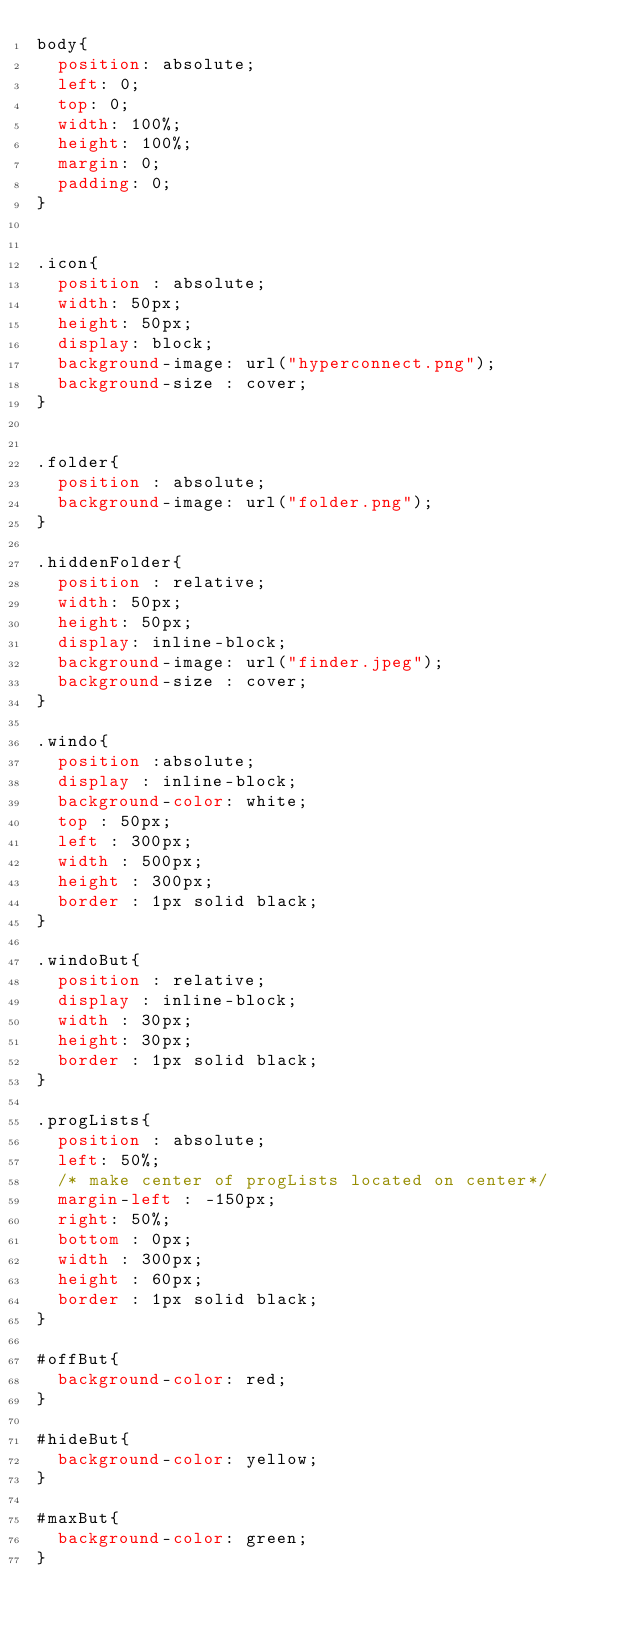Convert code to text. <code><loc_0><loc_0><loc_500><loc_500><_CSS_>body{
  position: absolute;
  left: 0;
  top: 0;
  width: 100%;
  height: 100%;
  margin: 0;
  padding: 0;
}


.icon{
  position : absolute;
  width: 50px;
  height: 50px;
  display: block;
  background-image: url("hyperconnect.png");
  background-size : cover;
}


.folder{
  position : absolute;
  background-image: url("folder.png");
}

.hiddenFolder{
  position : relative;
  width: 50px;
  height: 50px;
  display: inline-block;
  background-image: url("finder.jpeg");
  background-size : cover;
}

.windo{
  position :absolute;
  display : inline-block;
  background-color: white;
  top : 50px;
  left : 300px;
  width : 500px;
  height : 300px;
  border : 1px solid black;
}

.windoBut{
  position : relative;
  display : inline-block;
  width : 30px;
  height: 30px;
  border : 1px solid black;
}

.progLists{
  position : absolute;
  left: 50%;
  /* make center of progLists located on center*/
  margin-left : -150px;
  right: 50%;
  bottom : 0px;
  width : 300px;
  height : 60px;
  border : 1px solid black;
}

#offBut{
  background-color: red;
}

#hideBut{
  background-color: yellow;
}

#maxBut{
  background-color: green;
}
</code> 